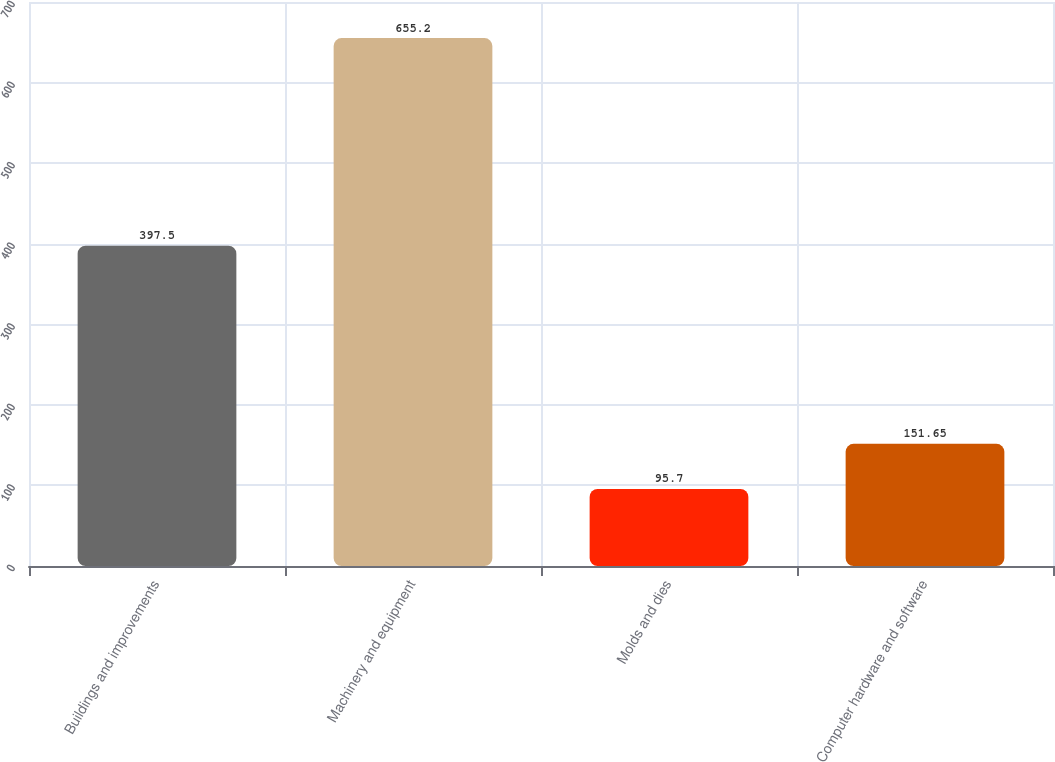<chart> <loc_0><loc_0><loc_500><loc_500><bar_chart><fcel>Buildings and improvements<fcel>Machinery and equipment<fcel>Molds and dies<fcel>Computer hardware and software<nl><fcel>397.5<fcel>655.2<fcel>95.7<fcel>151.65<nl></chart> 